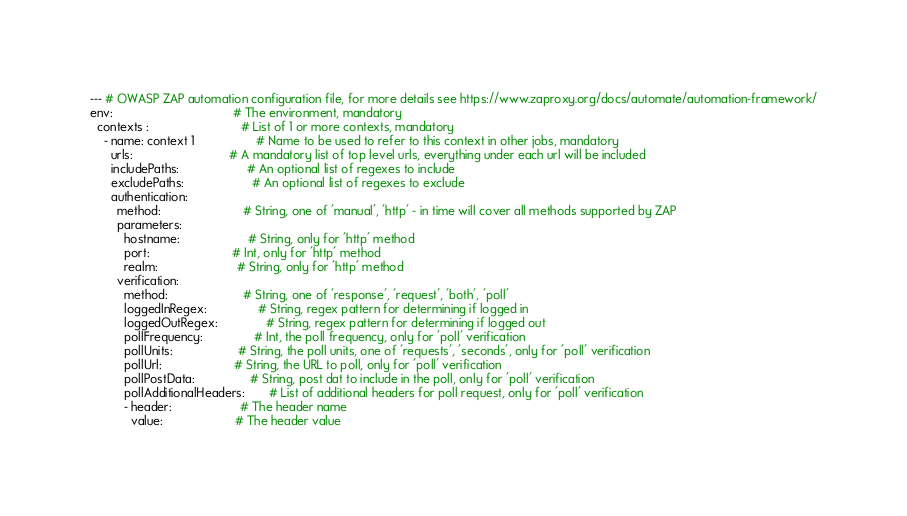Convert code to text. <code><loc_0><loc_0><loc_500><loc_500><_YAML_>--- # OWASP ZAP automation configuration file, for more details see https://www.zaproxy.org/docs/automate/automation-framework/
env:                                   # The environment, mandatory
  contexts :                           # List of 1 or more contexts, mandatory
    - name: context 1                  # Name to be used to refer to this context in other jobs, mandatory
      urls:                            # A mandatory list of top level urls, everything under each url will be included
      includePaths:                    # An optional list of regexes to include
      excludePaths:                    # An optional list of regexes to exclude
      authentication:
        method:                        # String, one of 'manual', 'http' - in time will cover all methods supported by ZAP
        parameters:
          hostname:                    # String, only for 'http' method
          port:                        # Int, only for 'http' method
          realm:                       # String, only for 'http' method
        verification:
          method:                      # String, one of 'response', 'request', 'both', 'poll'
          loggedInRegex:               # String, regex pattern for determining if logged in
          loggedOutRegex:              # String, regex pattern for determining if logged out
          pollFrequency:               # Int, the poll frequency, only for 'poll' verification
          pollUnits:                   # String, the poll units, one of 'requests', 'seconds', only for 'poll' verification
          pollUrl:                     # String, the URL to poll, only for 'poll' verification
          pollPostData:                # String, post dat to include in the poll, only for 'poll' verification
          pollAdditionalHeaders:       # List of additional headers for poll request, only for 'poll' verification
          - header:                    # The header name
            value:                     # The header value</code> 